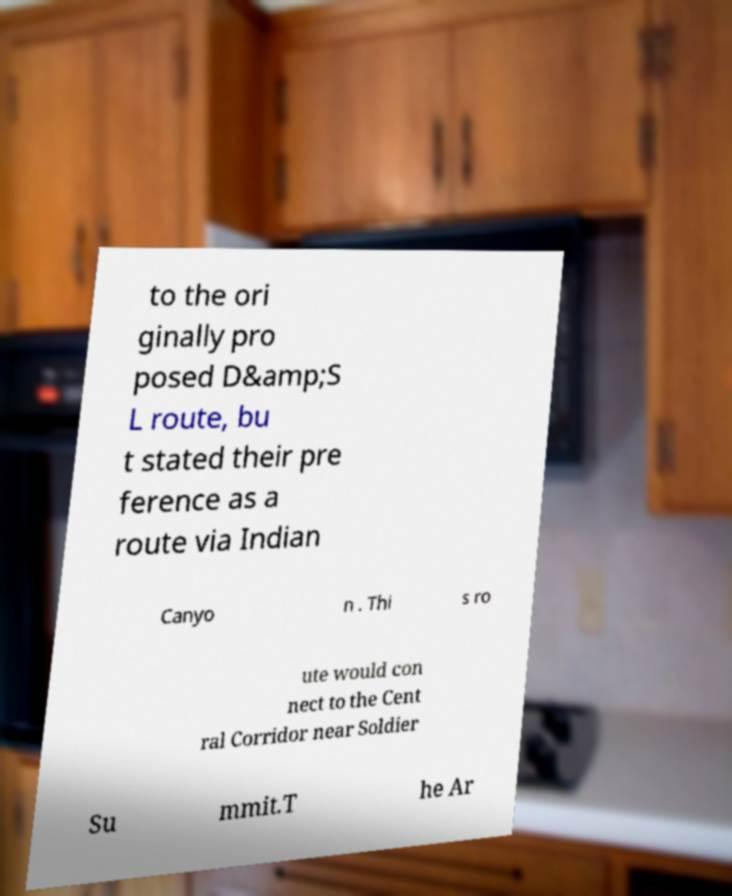Could you extract and type out the text from this image? to the ori ginally pro posed D&amp;S L route, bu t stated their pre ference as a route via Indian Canyo n . Thi s ro ute would con nect to the Cent ral Corridor near Soldier Su mmit.T he Ar 